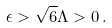Convert formula to latex. <formula><loc_0><loc_0><loc_500><loc_500>\epsilon > \sqrt { 6 } \Lambda > 0 \, .</formula> 